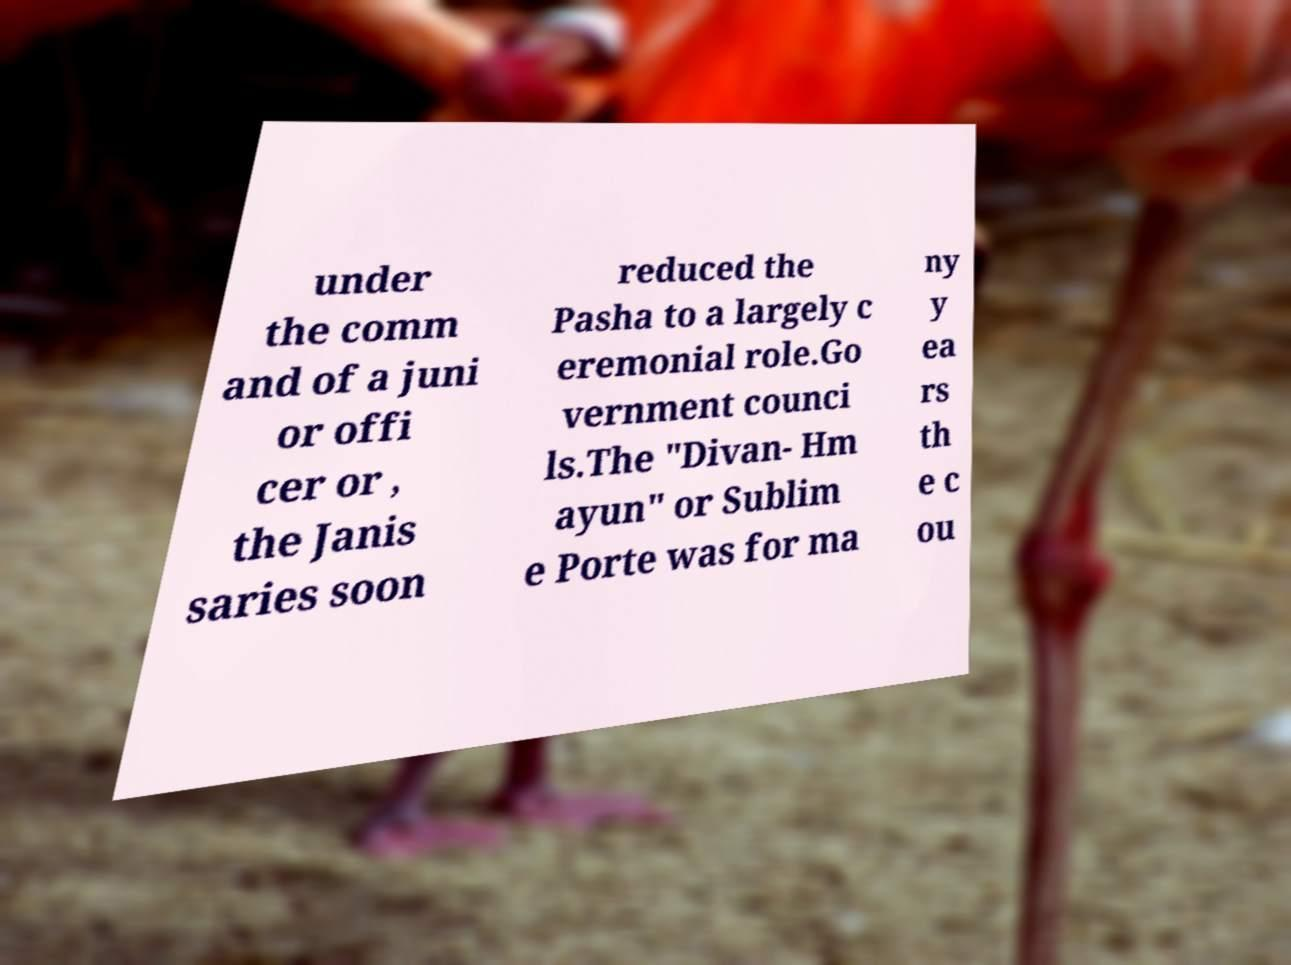Could you extract and type out the text from this image? under the comm and of a juni or offi cer or , the Janis saries soon reduced the Pasha to a largely c eremonial role.Go vernment counci ls.The "Divan- Hm ayun" or Sublim e Porte was for ma ny y ea rs th e c ou 